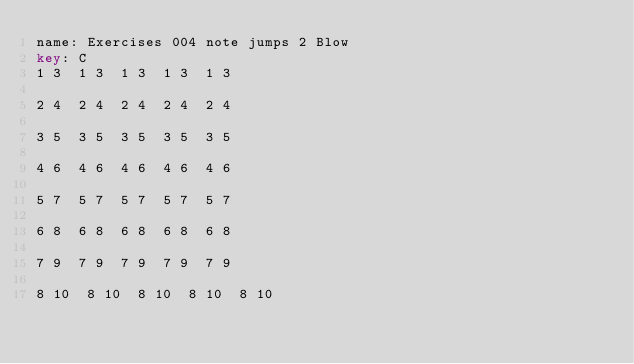<code> <loc_0><loc_0><loc_500><loc_500><_SQL_>name: Exercises 004 note jumps 2 Blow
key: C
1 3  1 3  1 3  1 3  1 3

2 4  2 4  2 4  2 4  2 4  

3 5  3 5  3 5  3 5  3 5

4 6  4 6  4 6  4 6  4 6  

5 7  5 7  5 7  5 7  5 7

6 8  6 8  6 8  6 8  6 8  

7 9  7 9  7 9  7 9  7 9  

8 10  8 10  8 10  8 10  8 10  </code> 